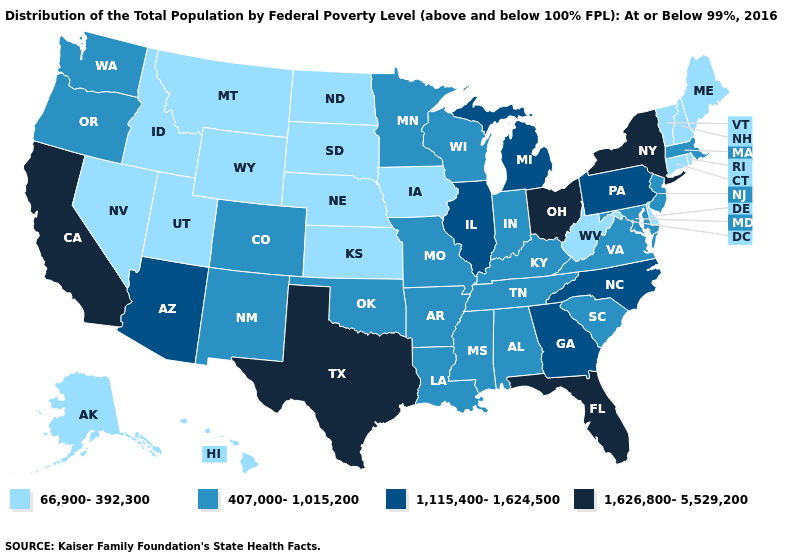Does Texas have the highest value in the USA?
Keep it brief. Yes. What is the value of Maryland?
Write a very short answer. 407,000-1,015,200. Name the states that have a value in the range 1,115,400-1,624,500?
Be succinct. Arizona, Georgia, Illinois, Michigan, North Carolina, Pennsylvania. What is the highest value in the West ?
Short answer required. 1,626,800-5,529,200. What is the highest value in the West ?
Answer briefly. 1,626,800-5,529,200. Name the states that have a value in the range 1,115,400-1,624,500?
Write a very short answer. Arizona, Georgia, Illinois, Michigan, North Carolina, Pennsylvania. Name the states that have a value in the range 1,115,400-1,624,500?
Quick response, please. Arizona, Georgia, Illinois, Michigan, North Carolina, Pennsylvania. Name the states that have a value in the range 407,000-1,015,200?
Give a very brief answer. Alabama, Arkansas, Colorado, Indiana, Kentucky, Louisiana, Maryland, Massachusetts, Minnesota, Mississippi, Missouri, New Jersey, New Mexico, Oklahoma, Oregon, South Carolina, Tennessee, Virginia, Washington, Wisconsin. What is the value of Hawaii?
Quick response, please. 66,900-392,300. Does the first symbol in the legend represent the smallest category?
Give a very brief answer. Yes. Does the map have missing data?
Answer briefly. No. Among the states that border Tennessee , does Arkansas have the highest value?
Short answer required. No. Does Indiana have a lower value than Hawaii?
Be succinct. No. Does New York have the highest value in the Northeast?
Keep it brief. Yes. What is the lowest value in the USA?
Give a very brief answer. 66,900-392,300. 